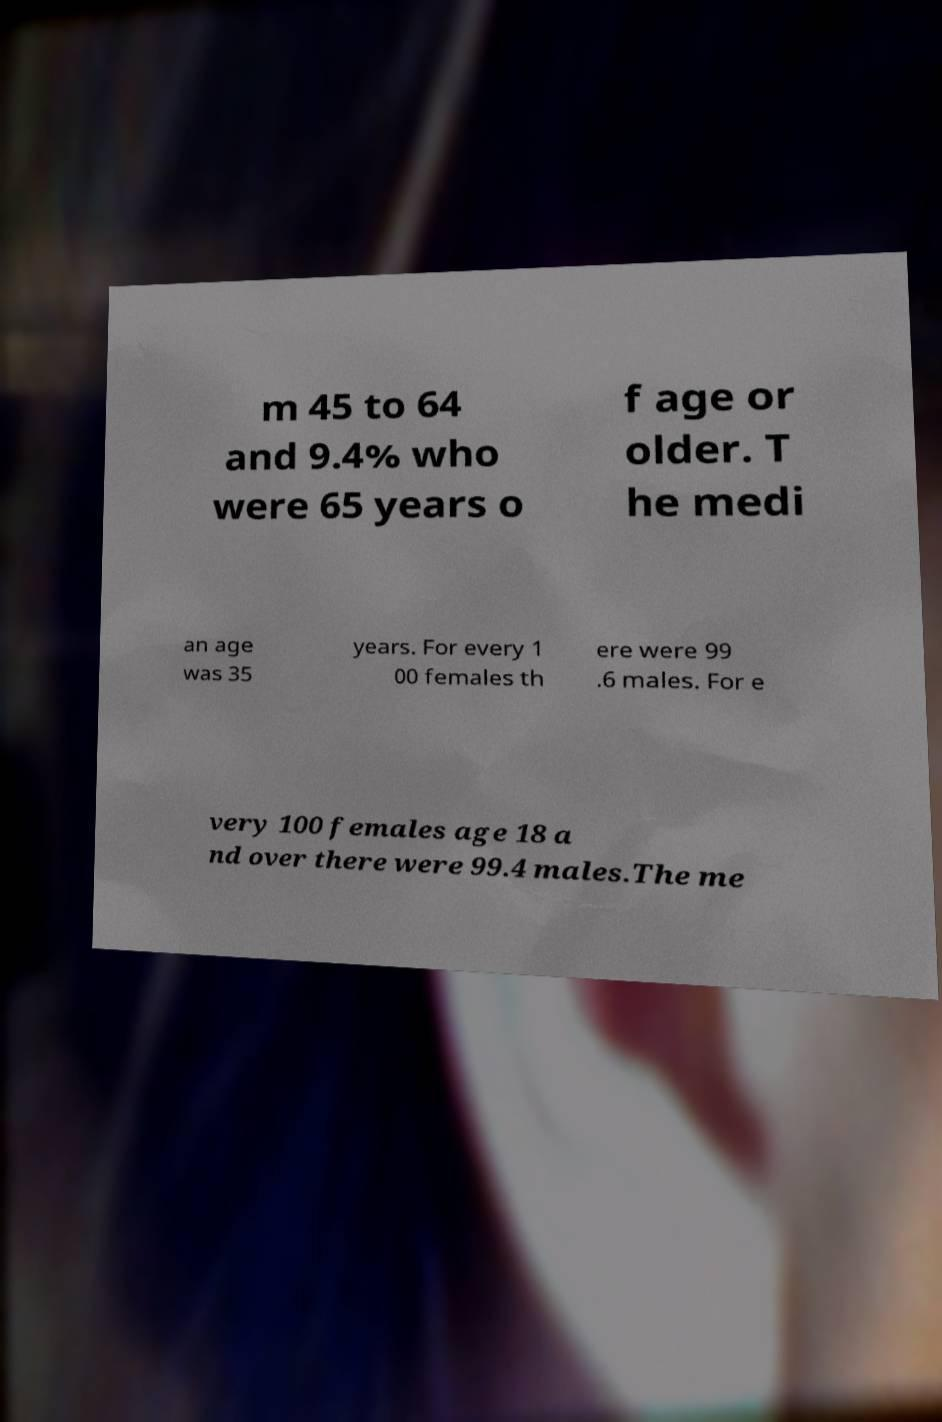What messages or text are displayed in this image? I need them in a readable, typed format. m 45 to 64 and 9.4% who were 65 years o f age or older. T he medi an age was 35 years. For every 1 00 females th ere were 99 .6 males. For e very 100 females age 18 a nd over there were 99.4 males.The me 